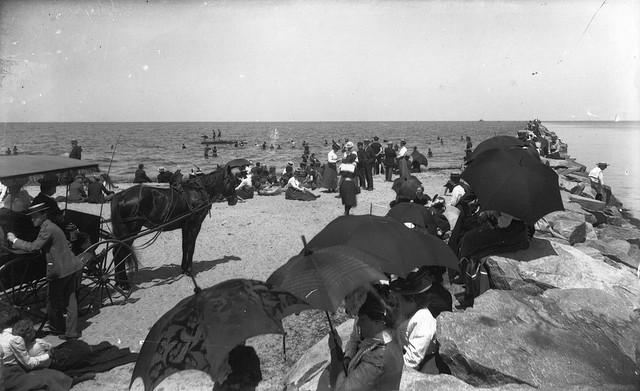What is the horse pulling?
Answer briefly. Carriage. Are they on a mountain?
Give a very brief answer. No. Is the photo black and white?
Short answer required. Yes. Is this location a public beach?
Quick response, please. Yes. 